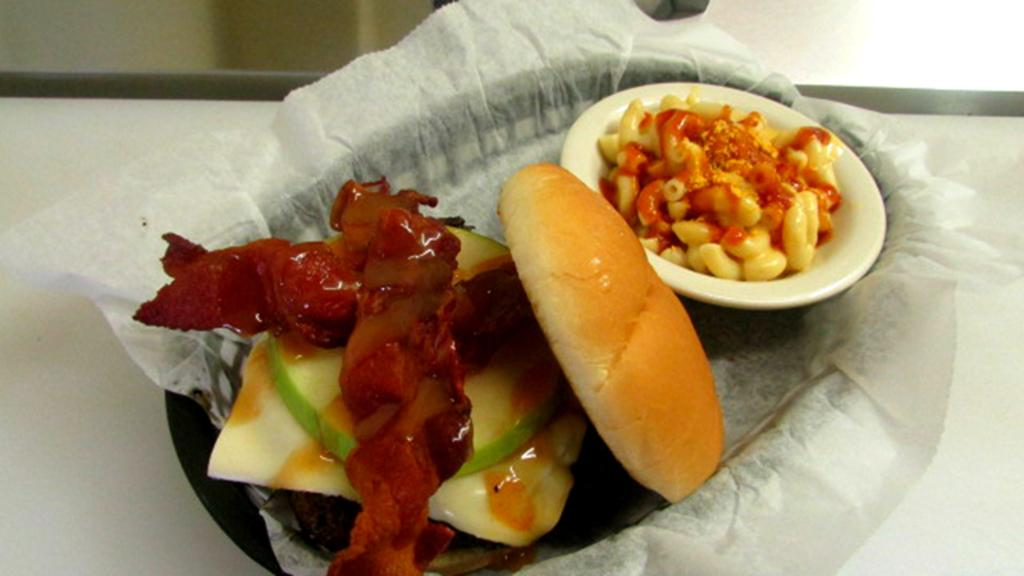What is on the plate that is visible in the image? There is a burger in the image. What type of food is in the bowl? There is pasta in the image. What is the liquid substance in the image? There is gravy in the image. What is used for cleaning or wiping in the image? Tissue is present in the image for cleaning or wiping. Where are all the items placed in the image? All items are placed on a table in the image. What type of line is used to hold the burger together in the image? There is no line present in the image; the burger is not held together by any visible line. What muscle is visible in the image? There are no muscles visible in the image; it features food items and tissue. 